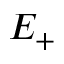Convert formula to latex. <formula><loc_0><loc_0><loc_500><loc_500>E _ { + }</formula> 